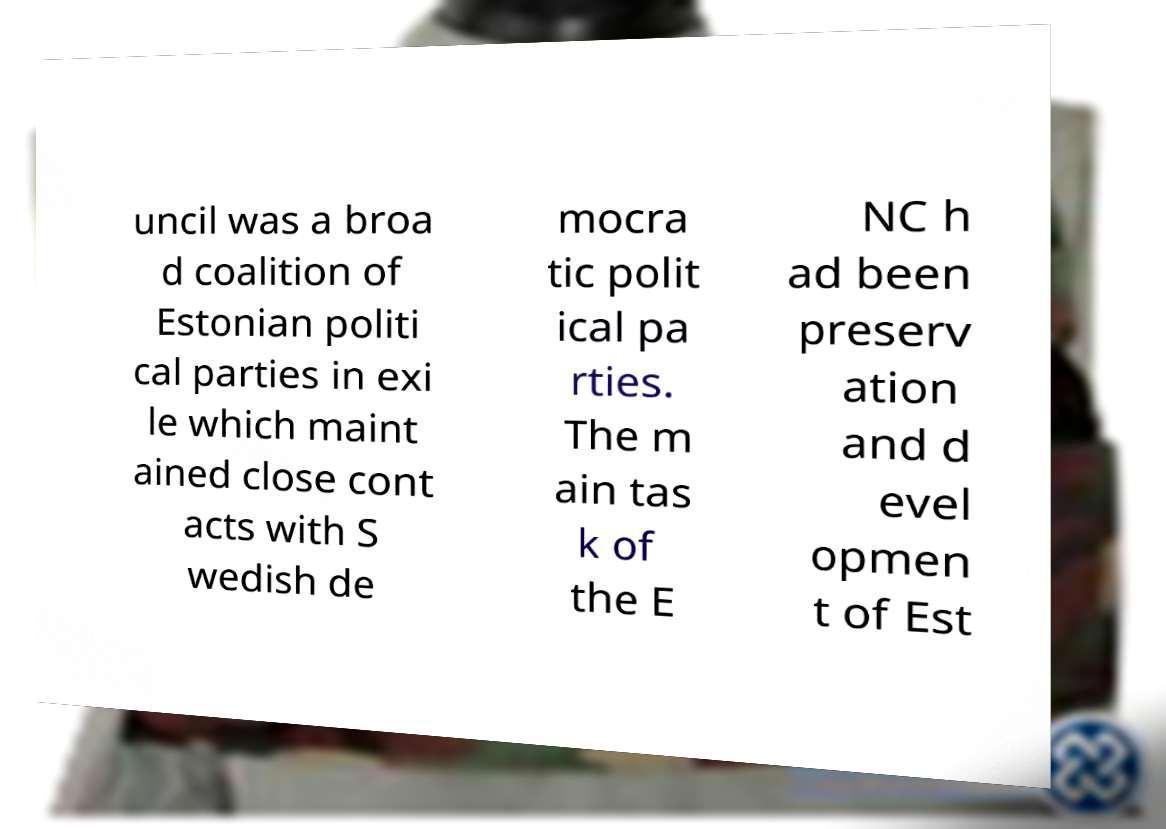Please identify and transcribe the text found in this image. uncil was a broa d coalition of Estonian politi cal parties in exi le which maint ained close cont acts with S wedish de mocra tic polit ical pa rties. The m ain tas k of the E NC h ad been preserv ation and d evel opmen t of Est 